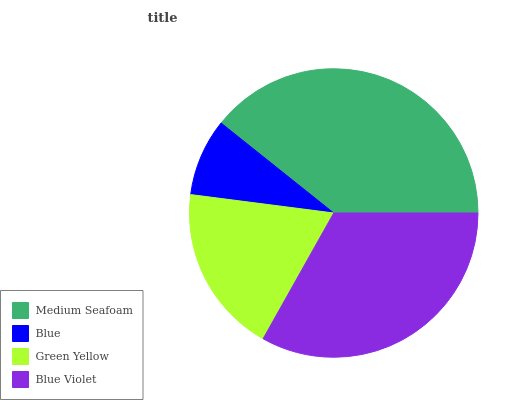Is Blue the minimum?
Answer yes or no. Yes. Is Medium Seafoam the maximum?
Answer yes or no. Yes. Is Green Yellow the minimum?
Answer yes or no. No. Is Green Yellow the maximum?
Answer yes or no. No. Is Green Yellow greater than Blue?
Answer yes or no. Yes. Is Blue less than Green Yellow?
Answer yes or no. Yes. Is Blue greater than Green Yellow?
Answer yes or no. No. Is Green Yellow less than Blue?
Answer yes or no. No. Is Blue Violet the high median?
Answer yes or no. Yes. Is Green Yellow the low median?
Answer yes or no. Yes. Is Medium Seafoam the high median?
Answer yes or no. No. Is Medium Seafoam the low median?
Answer yes or no. No. 